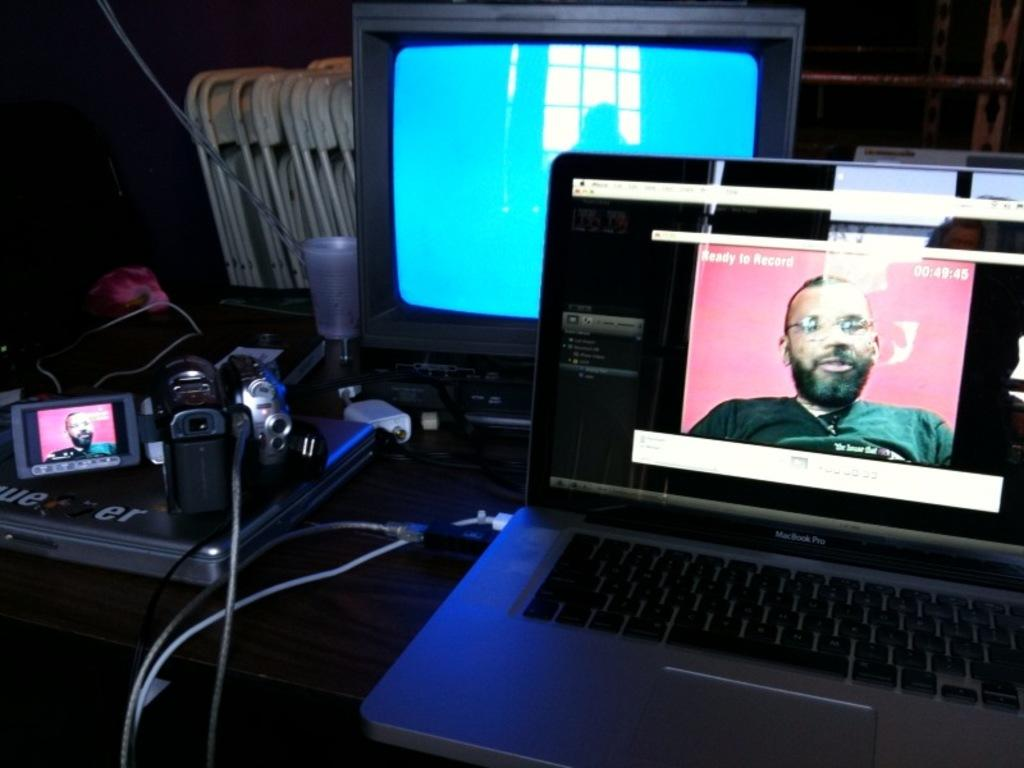Provide a one-sentence caption for the provided image. a macbook pro on the desk with an open window on it. 